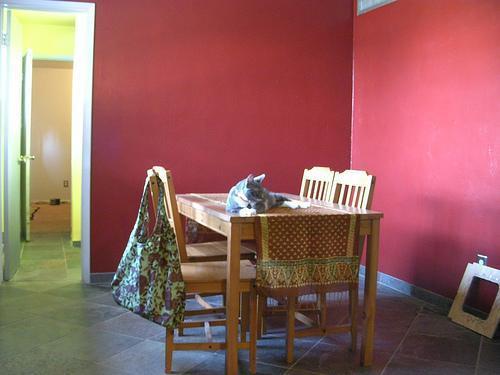How many chairs in the image?
Give a very brief answer. 3. 